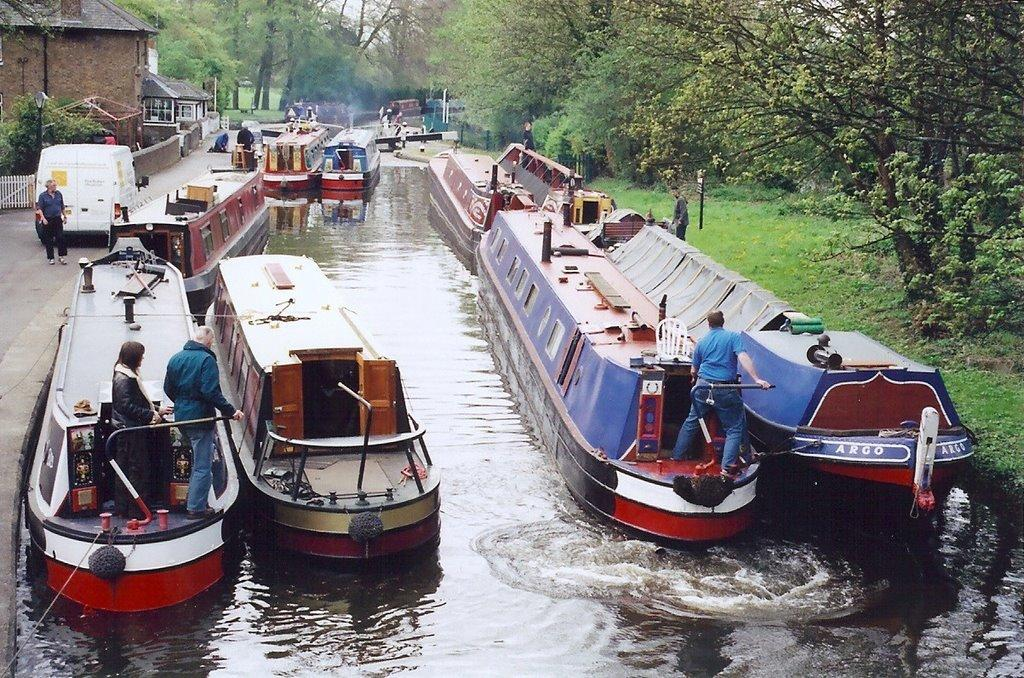<image>
Render a clear and concise summary of the photo. A few red, blue and white large boats with one being called Argo. 